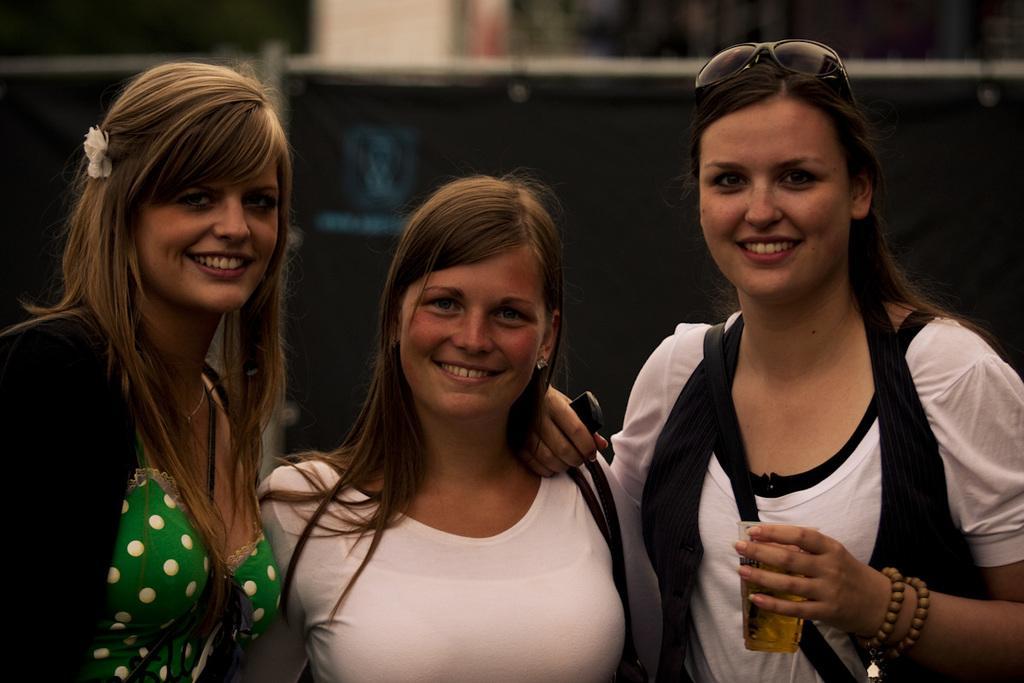Please provide a concise description of this image. In this image there are three women with a smile on their face, one of them is holding a glass of drink, behind them there is a partition fence with metal rod and cloth, behind them there is a wall. 